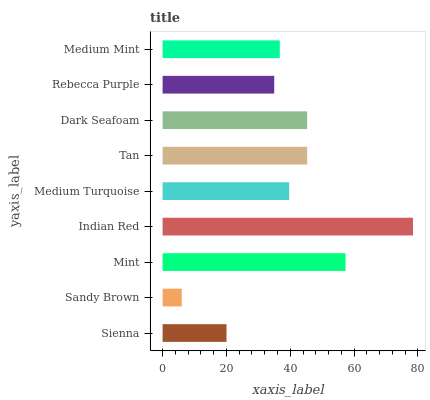Is Sandy Brown the minimum?
Answer yes or no. Yes. Is Indian Red the maximum?
Answer yes or no. Yes. Is Mint the minimum?
Answer yes or no. No. Is Mint the maximum?
Answer yes or no. No. Is Mint greater than Sandy Brown?
Answer yes or no. Yes. Is Sandy Brown less than Mint?
Answer yes or no. Yes. Is Sandy Brown greater than Mint?
Answer yes or no. No. Is Mint less than Sandy Brown?
Answer yes or no. No. Is Medium Turquoise the high median?
Answer yes or no. Yes. Is Medium Turquoise the low median?
Answer yes or no. Yes. Is Dark Seafoam the high median?
Answer yes or no. No. Is Medium Mint the low median?
Answer yes or no. No. 